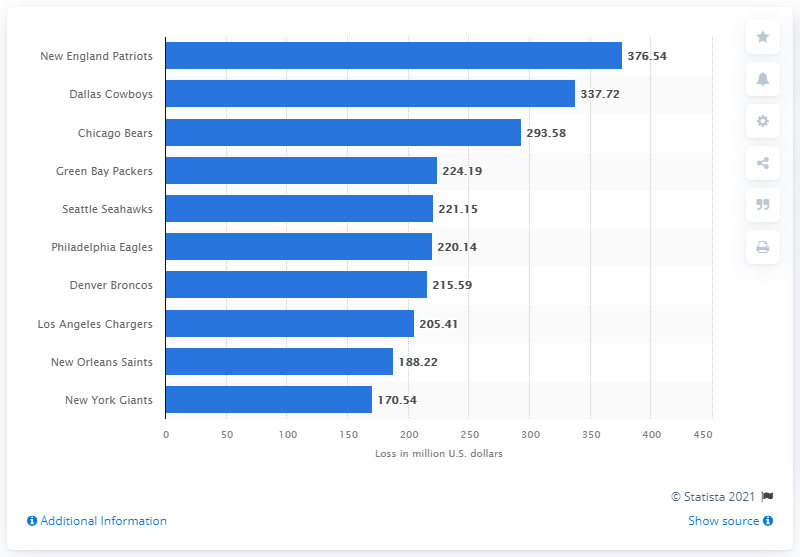Identify some key points in this picture. The New England Patriots could potentially lose a significant amount of money as a result of postponed games due to the COVID-19 pandemic. Specifically, the team could potentially lose 376.54 in revenue and expenses related to the cancelled games. 